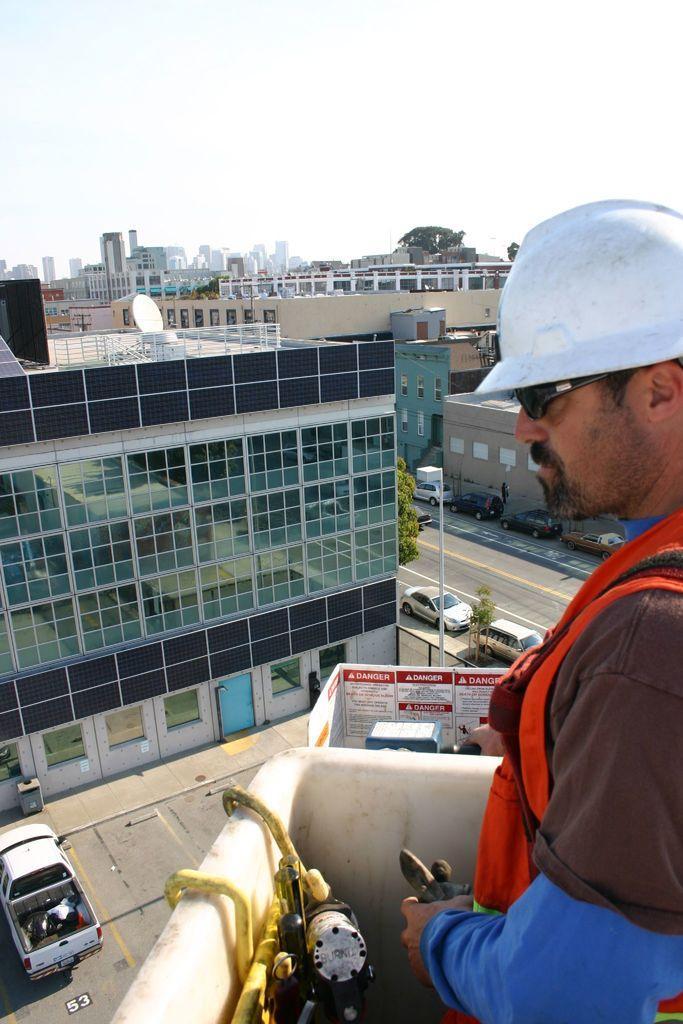Can you describe this image briefly? In this image I can see a person wearing blue, brown and orange colored dress and white color helmet is standing. I can see a building, the road, a tree and few vehicles. In the background I can see few buildings and the sky. 